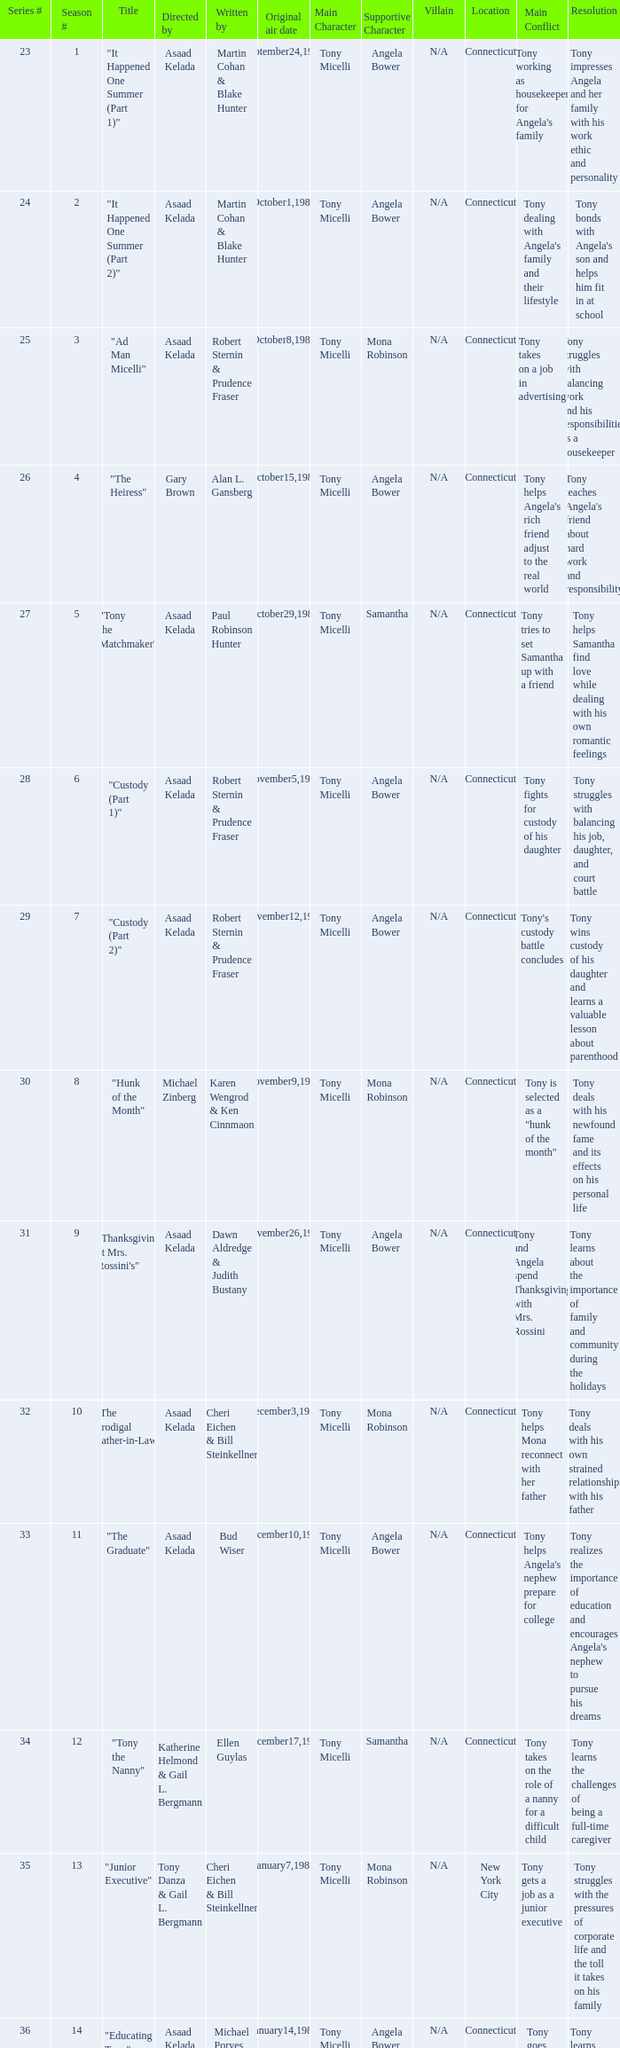Who were the authors of series episode #25? Robert Sternin & Prudence Fraser. Would you mind parsing the complete table? {'header': ['Series #', 'Season #', 'Title', 'Directed by', 'Written by', 'Original air date', 'Main Character', 'Supportive Character', 'Villain', 'Location', 'Main Conflict', 'Resolution'], 'rows': [['23', '1', '"It Happened One Summer (Part 1)"', 'Asaad Kelada', 'Martin Cohan & Blake Hunter', 'September24,1985', 'Tony Micelli', 'Angela Bower', 'N/A', 'Connecticut', "Tony working as housekeeper for Angela's family", 'Tony impresses Angela and her family with his work ethic and personality'], ['24', '2', '"It Happened One Summer (Part 2)"', 'Asaad Kelada', 'Martin Cohan & Blake Hunter', 'October1,1985', 'Tony Micelli', 'Angela Bower', 'N/A', 'Connecticut', "Tony dealing with Angela's family and their lifestyle", "Tony bonds with Angela's son and helps him fit in at school"], ['25', '3', '"Ad Man Micelli"', 'Asaad Kelada', 'Robert Sternin & Prudence Fraser', 'October8,1985', 'Tony Micelli', 'Mona Robinson', 'N/A', 'Connecticut', 'Tony takes on a job in advertising', 'Tony struggles with balancing work and his responsibilities as a housekeeper'], ['26', '4', '"The Heiress"', 'Gary Brown', 'Alan L. Gansberg', 'October15,1985', 'Tony Micelli', 'Angela Bower', 'N/A', 'Connecticut', "Tony helps Angela's rich friend adjust to the real world", "Tony teaches Angela's friend about hard work and responsibility"], ['27', '5', '"Tony the Matchmaker"', 'Asaad Kelada', 'Paul Robinson Hunter', 'October29,1985', 'Tony Micelli', 'Samantha', 'N/A', 'Connecticut', 'Tony tries to set Samantha up with a friend', 'Tony helps Samantha find love while dealing with his own romantic feelings'], ['28', '6', '"Custody (Part 1)"', 'Asaad Kelada', 'Robert Sternin & Prudence Fraser', 'November5,1985', 'Tony Micelli', 'Angela Bower', 'N/A', 'Connecticut', 'Tony fights for custody of his daughter', 'Tony struggles with balancing his job, daughter, and court battle'], ['29', '7', '"Custody (Part 2)"', 'Asaad Kelada', 'Robert Sternin & Prudence Fraser', 'November12,1985', 'Tony Micelli', 'Angela Bower', 'N/A', 'Connecticut', "Tony's custody battle concludes", 'Tony wins custody of his daughter and learns a valuable lesson about parenthood'], ['30', '8', '"Hunk of the Month"', 'Michael Zinberg', 'Karen Wengrod & Ken Cinnmaon', 'November9,1985', 'Tony Micelli', 'Mona Robinson', 'N/A', 'Connecticut', 'Tony is selected as a "hunk of the month"', 'Tony deals with his newfound fame and its effects on his personal life'], ['31', '9', '"Thanksgiving at Mrs. Rossini\'s"', 'Asaad Kelada', 'Dawn Aldredge & Judith Bustany', 'November26,1985', 'Tony Micelli', 'Angela Bower', 'N/A', 'Connecticut', 'Tony and Angela spend Thanksgiving with Mrs. Rossini', 'Tony learns about the importance of family and community during the holidays'], ['32', '10', '"The Prodigal Father-in-Law"', 'Asaad Kelada', 'Cheri Eichen & Bill Steinkellner', 'December3,1985', 'Tony Micelli', 'Mona Robinson', 'N/A', 'Connecticut', 'Tony helps Mona reconnect with her father', 'Tony deals with his own strained relationship with his father'], ['33', '11', '"The Graduate"', 'Asaad Kelada', 'Bud Wiser', 'December10,1985', 'Tony Micelli', 'Angela Bower', 'N/A', 'Connecticut', "Tony helps Angela's nephew prepare for college", "Tony realizes the importance of education and encourages Angela's nephew to pursue his dreams"], ['34', '12', '"Tony the Nanny"', 'Katherine Helmond & Gail L. Bergmann', 'Ellen Guylas', 'December17,1985', 'Tony Micelli', 'Samantha', 'N/A', 'Connecticut', 'Tony takes on the role of a nanny for a difficult child', 'Tony learns the challenges of being a full-time caregiver'], ['35', '13', '"Junior Executive"', 'Tony Danza & Gail L. Bergmann', 'Cheri Eichen & Bill Steinkellner', 'January7,1986', 'Tony Micelli', 'Mona Robinson', 'N/A', 'New York City', 'Tony gets a job as a junior executive', 'Tony struggles with the pressures of corporate life and the toll it takes on his family'], ['36', '14', '"Educating Tony"', 'Asaad Kelada', 'Michael Poryes', 'January14,1986', 'Tony Micelli', 'Angela Bower', 'N/A', 'Connecticut', 'Tony goes back to school', 'Tony learns about the importance of education and how it can improve his career prospects'], ['37', '15', '"Gotta Dance"', 'Asaad Kelada', 'Howard Meyers', 'January21,1986', 'Tony Micelli', 'Mona Robinson', 'N/A', 'Connecticut', 'Tony teaches a dance class', 'Tony learns about the importance of self-expression and following your passions'], ['38', '16', '"The Babysitter"', 'Asaad Kelada', 'Bud Wiser', 'January28,1986', 'Tony Micelli', 'Angela Bower', 'N/A', 'Connecticut', "Tony takes care of Angela's son while she's away", 'Tony learns the challenges of being a single parent'], ['39', '17', '"Jonathan Plays Cupid "', 'Asaad Kelada', 'Paul Robinson Hunter', 'February11,1986', 'Tony Micelli', 'Angela Bower', 'N/A', 'Connecticut', 'Tony helps Jonathan set up a romantic evening', 'Tony reflects on his own romantic life and learns about the importance of love and connection'], ['40', '18', '"When Worlds Collide"', 'Asaad Kelada', 'Karen Wengrod & Ken Cinnamon', 'February18,1986', 'Tony Micelli', 'Mona Robinson', 'N/A', 'Connecticut', "Tony's ex-wife comes to town", 'Tony learns to navigate his complicated relationships and focus on his priorities'], ['41', '19', '"Losers and Other Strangers"', 'Asaad Kelada', 'Seth Weisbord', 'February25,1986', 'Tony Micelli', 'Angela Bower', 'N/A', 'Connecticut', 'Tony throws a party for his disabled friend', 'Tony learns about empathy and the challenges faced by those with disabilities'], ['42', '20', '"Tony for President"', 'Asaad Kelada', 'Howard Meyers', 'March4,1986', 'Tony Micelli', 'Mona Robinson', 'N/A', 'Connecticut', 'Tony runs for local office', 'Tony learns about the challenges of politics and the importance of civic duty'], ['43', '21', '"Not With My Client, You Don\'t"', 'Asaad Kelada', 'Dawn Aldredge & Judith Bustany', 'March18,1986', 'Tony Micelli', 'Angela Bower', 'N/A', 'Connecticut', 'Tony helps Angela with a difficult client', 'Tony learns about the importance of loyalty and trust in business relationships'], ['45', '23', '"There\'s No Business Like Shoe Business"', 'Asaad Kelada', 'Karen Wengrod & Ken Cinnamon', 'April1,1986', 'Tony Micelli', 'Mona Robinson', 'N/A', 'New York City', 'Tony attends a shoe conference', 'Tony learns about the importance of networking and marketing in business'], ['46', '24', '"The Unnatural"', 'Jim Drake', 'Ellen Guylas', 'April8,1986', 'Tony Micelli', 'Angela Bower', 'N/A', 'Connecticut', "Tony coaches Angela's son's baseball team", 'Tony learns about sportsmanship and the importance of having fun while playing sports.']]} 